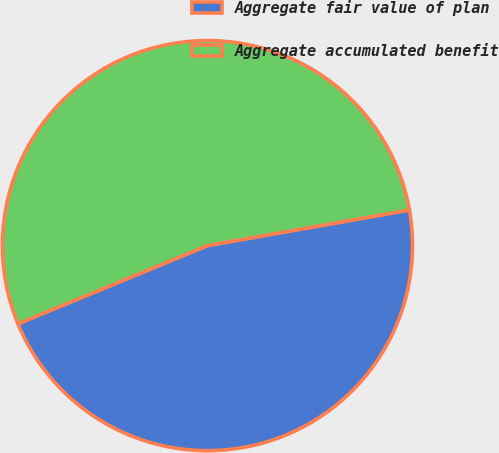Convert chart to OTSL. <chart><loc_0><loc_0><loc_500><loc_500><pie_chart><fcel>Aggregate fair value of plan<fcel>Aggregate accumulated benefit<nl><fcel>46.55%<fcel>53.45%<nl></chart> 